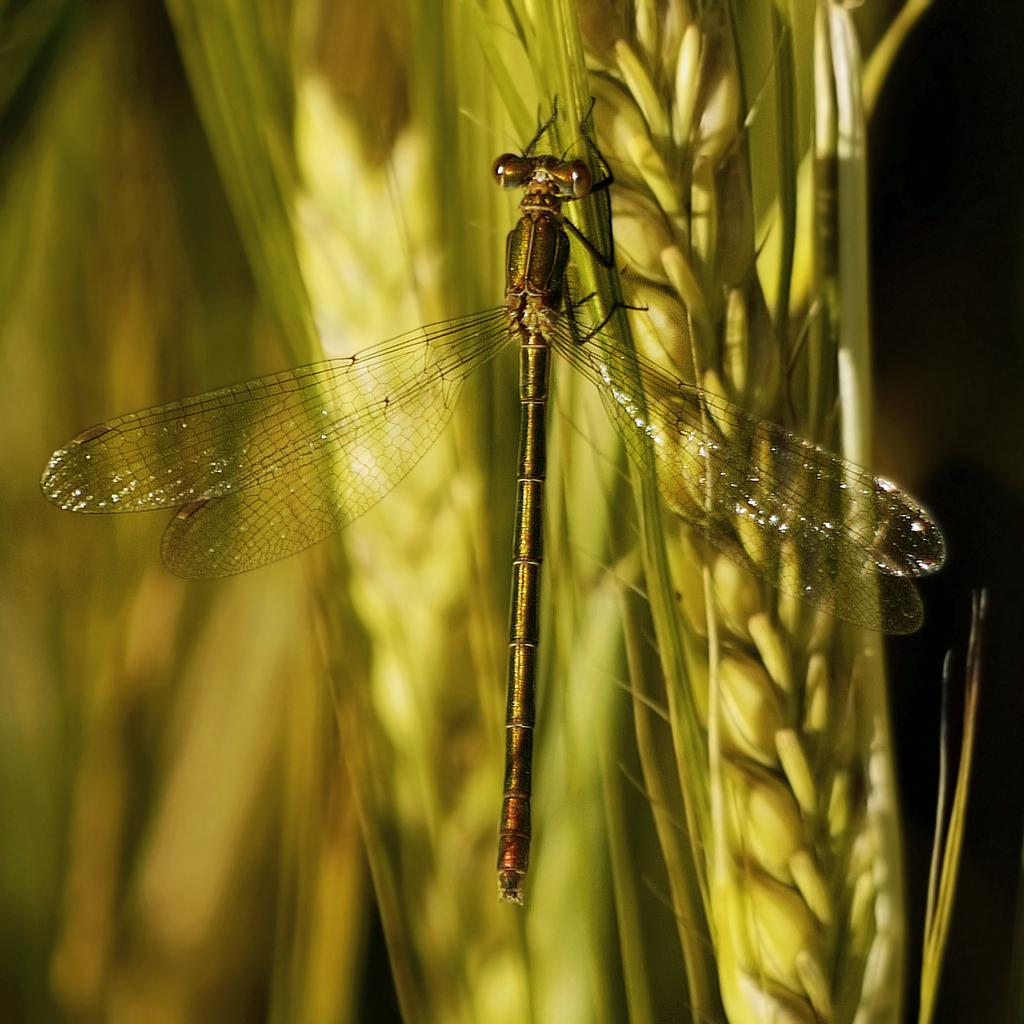What insect is present in the image? There is a dragonfly in the image. What is the dragonfly resting on? The dragonfly is on a crop. Can you describe the background of the image? The background of the image is blurred. What type of nerve can be seen in the image? There is no nerve present in the image; it features a dragonfly on a crop with a blurred background. 